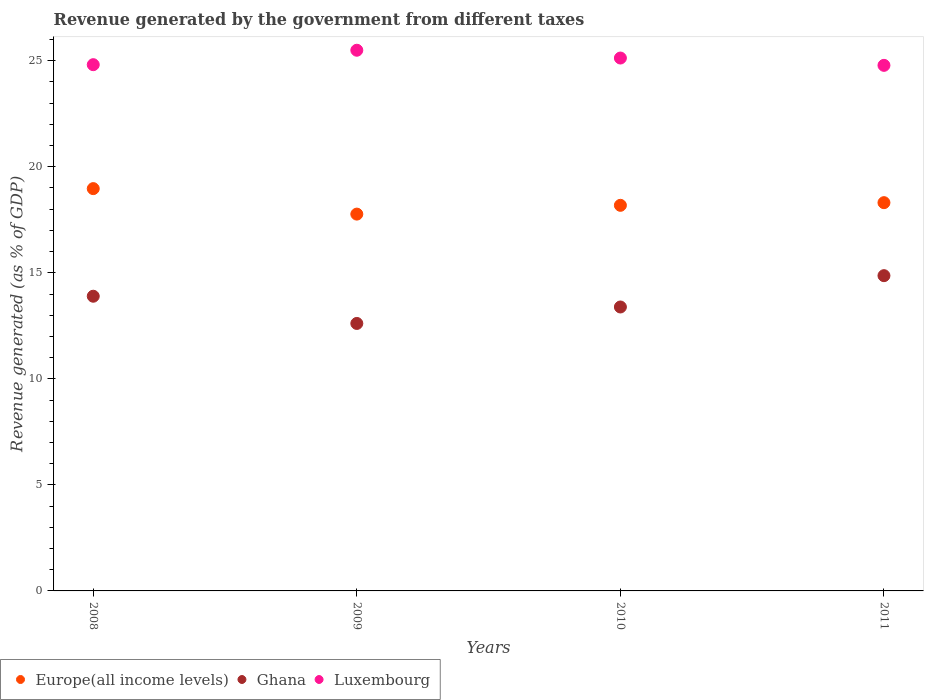How many different coloured dotlines are there?
Your answer should be compact. 3. Is the number of dotlines equal to the number of legend labels?
Ensure brevity in your answer.  Yes. What is the revenue generated by the government in Europe(all income levels) in 2011?
Make the answer very short. 18.31. Across all years, what is the maximum revenue generated by the government in Ghana?
Your response must be concise. 14.87. Across all years, what is the minimum revenue generated by the government in Luxembourg?
Provide a short and direct response. 24.78. What is the total revenue generated by the government in Ghana in the graph?
Offer a very short reply. 54.76. What is the difference between the revenue generated by the government in Ghana in 2009 and that in 2010?
Your response must be concise. -0.78. What is the difference between the revenue generated by the government in Europe(all income levels) in 2011 and the revenue generated by the government in Luxembourg in 2010?
Your response must be concise. -6.82. What is the average revenue generated by the government in Ghana per year?
Your response must be concise. 13.69. In the year 2011, what is the difference between the revenue generated by the government in Ghana and revenue generated by the government in Europe(all income levels)?
Make the answer very short. -3.44. In how many years, is the revenue generated by the government in Ghana greater than 19 %?
Make the answer very short. 0. What is the ratio of the revenue generated by the government in Ghana in 2009 to that in 2011?
Your answer should be compact. 0.85. Is the revenue generated by the government in Europe(all income levels) in 2008 less than that in 2011?
Give a very brief answer. No. Is the difference between the revenue generated by the government in Ghana in 2010 and 2011 greater than the difference between the revenue generated by the government in Europe(all income levels) in 2010 and 2011?
Your answer should be very brief. No. What is the difference between the highest and the second highest revenue generated by the government in Europe(all income levels)?
Give a very brief answer. 0.66. What is the difference between the highest and the lowest revenue generated by the government in Luxembourg?
Make the answer very short. 0.71. Is it the case that in every year, the sum of the revenue generated by the government in Ghana and revenue generated by the government in Europe(all income levels)  is greater than the revenue generated by the government in Luxembourg?
Offer a very short reply. Yes. Does the revenue generated by the government in Ghana monotonically increase over the years?
Your response must be concise. No. How many dotlines are there?
Ensure brevity in your answer.  3. How many years are there in the graph?
Make the answer very short. 4. What is the difference between two consecutive major ticks on the Y-axis?
Keep it short and to the point. 5. Does the graph contain any zero values?
Provide a succinct answer. No. Does the graph contain grids?
Offer a terse response. No. What is the title of the graph?
Your answer should be very brief. Revenue generated by the government from different taxes. What is the label or title of the Y-axis?
Your response must be concise. Revenue generated (as % of GDP). What is the Revenue generated (as % of GDP) of Europe(all income levels) in 2008?
Provide a succinct answer. 18.97. What is the Revenue generated (as % of GDP) in Ghana in 2008?
Provide a short and direct response. 13.9. What is the Revenue generated (as % of GDP) of Luxembourg in 2008?
Your response must be concise. 24.81. What is the Revenue generated (as % of GDP) in Europe(all income levels) in 2009?
Keep it short and to the point. 17.77. What is the Revenue generated (as % of GDP) in Ghana in 2009?
Make the answer very short. 12.61. What is the Revenue generated (as % of GDP) in Luxembourg in 2009?
Provide a succinct answer. 25.5. What is the Revenue generated (as % of GDP) of Europe(all income levels) in 2010?
Your answer should be very brief. 18.18. What is the Revenue generated (as % of GDP) of Ghana in 2010?
Provide a succinct answer. 13.39. What is the Revenue generated (as % of GDP) in Luxembourg in 2010?
Provide a succinct answer. 25.13. What is the Revenue generated (as % of GDP) of Europe(all income levels) in 2011?
Your answer should be compact. 18.31. What is the Revenue generated (as % of GDP) in Ghana in 2011?
Offer a very short reply. 14.87. What is the Revenue generated (as % of GDP) of Luxembourg in 2011?
Make the answer very short. 24.78. Across all years, what is the maximum Revenue generated (as % of GDP) of Europe(all income levels)?
Provide a succinct answer. 18.97. Across all years, what is the maximum Revenue generated (as % of GDP) of Ghana?
Give a very brief answer. 14.87. Across all years, what is the maximum Revenue generated (as % of GDP) of Luxembourg?
Your answer should be compact. 25.5. Across all years, what is the minimum Revenue generated (as % of GDP) of Europe(all income levels)?
Your response must be concise. 17.77. Across all years, what is the minimum Revenue generated (as % of GDP) of Ghana?
Offer a terse response. 12.61. Across all years, what is the minimum Revenue generated (as % of GDP) in Luxembourg?
Provide a short and direct response. 24.78. What is the total Revenue generated (as % of GDP) of Europe(all income levels) in the graph?
Give a very brief answer. 73.23. What is the total Revenue generated (as % of GDP) of Ghana in the graph?
Offer a very short reply. 54.76. What is the total Revenue generated (as % of GDP) of Luxembourg in the graph?
Give a very brief answer. 100.22. What is the difference between the Revenue generated (as % of GDP) in Europe(all income levels) in 2008 and that in 2009?
Provide a short and direct response. 1.2. What is the difference between the Revenue generated (as % of GDP) of Ghana in 2008 and that in 2009?
Keep it short and to the point. 1.28. What is the difference between the Revenue generated (as % of GDP) of Luxembourg in 2008 and that in 2009?
Give a very brief answer. -0.68. What is the difference between the Revenue generated (as % of GDP) in Europe(all income levels) in 2008 and that in 2010?
Offer a very short reply. 0.79. What is the difference between the Revenue generated (as % of GDP) of Ghana in 2008 and that in 2010?
Your answer should be very brief. 0.51. What is the difference between the Revenue generated (as % of GDP) of Luxembourg in 2008 and that in 2010?
Offer a terse response. -0.31. What is the difference between the Revenue generated (as % of GDP) in Europe(all income levels) in 2008 and that in 2011?
Your answer should be very brief. 0.66. What is the difference between the Revenue generated (as % of GDP) of Ghana in 2008 and that in 2011?
Offer a terse response. -0.97. What is the difference between the Revenue generated (as % of GDP) in Luxembourg in 2008 and that in 2011?
Keep it short and to the point. 0.03. What is the difference between the Revenue generated (as % of GDP) in Europe(all income levels) in 2009 and that in 2010?
Give a very brief answer. -0.41. What is the difference between the Revenue generated (as % of GDP) of Ghana in 2009 and that in 2010?
Your response must be concise. -0.78. What is the difference between the Revenue generated (as % of GDP) in Luxembourg in 2009 and that in 2010?
Offer a terse response. 0.37. What is the difference between the Revenue generated (as % of GDP) in Europe(all income levels) in 2009 and that in 2011?
Give a very brief answer. -0.54. What is the difference between the Revenue generated (as % of GDP) in Ghana in 2009 and that in 2011?
Your response must be concise. -2.25. What is the difference between the Revenue generated (as % of GDP) of Luxembourg in 2009 and that in 2011?
Keep it short and to the point. 0.71. What is the difference between the Revenue generated (as % of GDP) in Europe(all income levels) in 2010 and that in 2011?
Offer a very short reply. -0.13. What is the difference between the Revenue generated (as % of GDP) of Ghana in 2010 and that in 2011?
Your response must be concise. -1.48. What is the difference between the Revenue generated (as % of GDP) in Luxembourg in 2010 and that in 2011?
Keep it short and to the point. 0.34. What is the difference between the Revenue generated (as % of GDP) of Europe(all income levels) in 2008 and the Revenue generated (as % of GDP) of Ghana in 2009?
Provide a short and direct response. 6.36. What is the difference between the Revenue generated (as % of GDP) of Europe(all income levels) in 2008 and the Revenue generated (as % of GDP) of Luxembourg in 2009?
Your answer should be compact. -6.53. What is the difference between the Revenue generated (as % of GDP) in Ghana in 2008 and the Revenue generated (as % of GDP) in Luxembourg in 2009?
Offer a terse response. -11.6. What is the difference between the Revenue generated (as % of GDP) of Europe(all income levels) in 2008 and the Revenue generated (as % of GDP) of Ghana in 2010?
Give a very brief answer. 5.58. What is the difference between the Revenue generated (as % of GDP) in Europe(all income levels) in 2008 and the Revenue generated (as % of GDP) in Luxembourg in 2010?
Your answer should be very brief. -6.16. What is the difference between the Revenue generated (as % of GDP) of Ghana in 2008 and the Revenue generated (as % of GDP) of Luxembourg in 2010?
Provide a succinct answer. -11.23. What is the difference between the Revenue generated (as % of GDP) in Europe(all income levels) in 2008 and the Revenue generated (as % of GDP) in Ghana in 2011?
Keep it short and to the point. 4.1. What is the difference between the Revenue generated (as % of GDP) of Europe(all income levels) in 2008 and the Revenue generated (as % of GDP) of Luxembourg in 2011?
Offer a terse response. -5.81. What is the difference between the Revenue generated (as % of GDP) in Ghana in 2008 and the Revenue generated (as % of GDP) in Luxembourg in 2011?
Provide a succinct answer. -10.89. What is the difference between the Revenue generated (as % of GDP) of Europe(all income levels) in 2009 and the Revenue generated (as % of GDP) of Ghana in 2010?
Offer a terse response. 4.38. What is the difference between the Revenue generated (as % of GDP) of Europe(all income levels) in 2009 and the Revenue generated (as % of GDP) of Luxembourg in 2010?
Offer a very short reply. -7.36. What is the difference between the Revenue generated (as % of GDP) in Ghana in 2009 and the Revenue generated (as % of GDP) in Luxembourg in 2010?
Keep it short and to the point. -12.52. What is the difference between the Revenue generated (as % of GDP) in Europe(all income levels) in 2009 and the Revenue generated (as % of GDP) in Ghana in 2011?
Offer a terse response. 2.9. What is the difference between the Revenue generated (as % of GDP) in Europe(all income levels) in 2009 and the Revenue generated (as % of GDP) in Luxembourg in 2011?
Keep it short and to the point. -7.01. What is the difference between the Revenue generated (as % of GDP) of Ghana in 2009 and the Revenue generated (as % of GDP) of Luxembourg in 2011?
Ensure brevity in your answer.  -12.17. What is the difference between the Revenue generated (as % of GDP) of Europe(all income levels) in 2010 and the Revenue generated (as % of GDP) of Ghana in 2011?
Ensure brevity in your answer.  3.32. What is the difference between the Revenue generated (as % of GDP) of Europe(all income levels) in 2010 and the Revenue generated (as % of GDP) of Luxembourg in 2011?
Provide a short and direct response. -6.6. What is the difference between the Revenue generated (as % of GDP) of Ghana in 2010 and the Revenue generated (as % of GDP) of Luxembourg in 2011?
Offer a terse response. -11.39. What is the average Revenue generated (as % of GDP) in Europe(all income levels) per year?
Keep it short and to the point. 18.31. What is the average Revenue generated (as % of GDP) of Ghana per year?
Your answer should be compact. 13.69. What is the average Revenue generated (as % of GDP) of Luxembourg per year?
Provide a short and direct response. 25.05. In the year 2008, what is the difference between the Revenue generated (as % of GDP) of Europe(all income levels) and Revenue generated (as % of GDP) of Ghana?
Your response must be concise. 5.07. In the year 2008, what is the difference between the Revenue generated (as % of GDP) of Europe(all income levels) and Revenue generated (as % of GDP) of Luxembourg?
Make the answer very short. -5.84. In the year 2008, what is the difference between the Revenue generated (as % of GDP) of Ghana and Revenue generated (as % of GDP) of Luxembourg?
Your response must be concise. -10.92. In the year 2009, what is the difference between the Revenue generated (as % of GDP) in Europe(all income levels) and Revenue generated (as % of GDP) in Ghana?
Offer a terse response. 5.16. In the year 2009, what is the difference between the Revenue generated (as % of GDP) in Europe(all income levels) and Revenue generated (as % of GDP) in Luxembourg?
Keep it short and to the point. -7.73. In the year 2009, what is the difference between the Revenue generated (as % of GDP) of Ghana and Revenue generated (as % of GDP) of Luxembourg?
Offer a very short reply. -12.88. In the year 2010, what is the difference between the Revenue generated (as % of GDP) of Europe(all income levels) and Revenue generated (as % of GDP) of Ghana?
Provide a short and direct response. 4.79. In the year 2010, what is the difference between the Revenue generated (as % of GDP) of Europe(all income levels) and Revenue generated (as % of GDP) of Luxembourg?
Keep it short and to the point. -6.95. In the year 2010, what is the difference between the Revenue generated (as % of GDP) in Ghana and Revenue generated (as % of GDP) in Luxembourg?
Offer a terse response. -11.74. In the year 2011, what is the difference between the Revenue generated (as % of GDP) in Europe(all income levels) and Revenue generated (as % of GDP) in Ghana?
Offer a terse response. 3.44. In the year 2011, what is the difference between the Revenue generated (as % of GDP) in Europe(all income levels) and Revenue generated (as % of GDP) in Luxembourg?
Your response must be concise. -6.47. In the year 2011, what is the difference between the Revenue generated (as % of GDP) of Ghana and Revenue generated (as % of GDP) of Luxembourg?
Make the answer very short. -9.92. What is the ratio of the Revenue generated (as % of GDP) of Europe(all income levels) in 2008 to that in 2009?
Give a very brief answer. 1.07. What is the ratio of the Revenue generated (as % of GDP) of Ghana in 2008 to that in 2009?
Provide a short and direct response. 1.1. What is the ratio of the Revenue generated (as % of GDP) of Luxembourg in 2008 to that in 2009?
Ensure brevity in your answer.  0.97. What is the ratio of the Revenue generated (as % of GDP) in Europe(all income levels) in 2008 to that in 2010?
Your answer should be very brief. 1.04. What is the ratio of the Revenue generated (as % of GDP) in Ghana in 2008 to that in 2010?
Make the answer very short. 1.04. What is the ratio of the Revenue generated (as % of GDP) in Luxembourg in 2008 to that in 2010?
Keep it short and to the point. 0.99. What is the ratio of the Revenue generated (as % of GDP) of Europe(all income levels) in 2008 to that in 2011?
Offer a very short reply. 1.04. What is the ratio of the Revenue generated (as % of GDP) in Ghana in 2008 to that in 2011?
Provide a short and direct response. 0.93. What is the ratio of the Revenue generated (as % of GDP) of Europe(all income levels) in 2009 to that in 2010?
Your answer should be compact. 0.98. What is the ratio of the Revenue generated (as % of GDP) of Ghana in 2009 to that in 2010?
Your response must be concise. 0.94. What is the ratio of the Revenue generated (as % of GDP) of Luxembourg in 2009 to that in 2010?
Your response must be concise. 1.01. What is the ratio of the Revenue generated (as % of GDP) of Europe(all income levels) in 2009 to that in 2011?
Provide a succinct answer. 0.97. What is the ratio of the Revenue generated (as % of GDP) in Ghana in 2009 to that in 2011?
Ensure brevity in your answer.  0.85. What is the ratio of the Revenue generated (as % of GDP) in Luxembourg in 2009 to that in 2011?
Give a very brief answer. 1.03. What is the ratio of the Revenue generated (as % of GDP) in Ghana in 2010 to that in 2011?
Your answer should be very brief. 0.9. What is the ratio of the Revenue generated (as % of GDP) of Luxembourg in 2010 to that in 2011?
Keep it short and to the point. 1.01. What is the difference between the highest and the second highest Revenue generated (as % of GDP) of Europe(all income levels)?
Make the answer very short. 0.66. What is the difference between the highest and the second highest Revenue generated (as % of GDP) in Ghana?
Provide a succinct answer. 0.97. What is the difference between the highest and the second highest Revenue generated (as % of GDP) of Luxembourg?
Keep it short and to the point. 0.37. What is the difference between the highest and the lowest Revenue generated (as % of GDP) of Europe(all income levels)?
Make the answer very short. 1.2. What is the difference between the highest and the lowest Revenue generated (as % of GDP) in Ghana?
Keep it short and to the point. 2.25. What is the difference between the highest and the lowest Revenue generated (as % of GDP) of Luxembourg?
Make the answer very short. 0.71. 